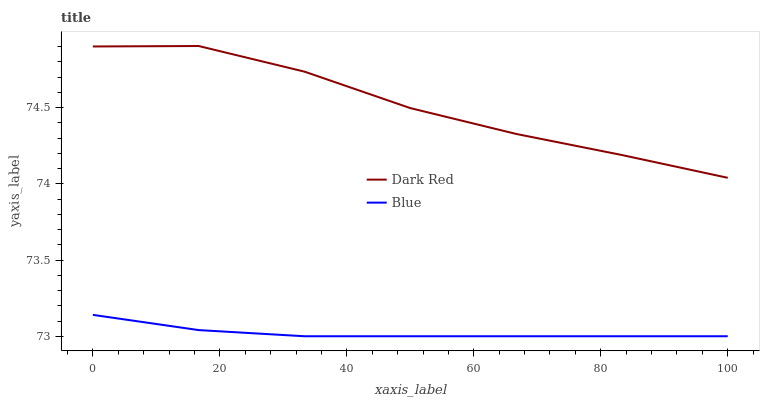Does Blue have the minimum area under the curve?
Answer yes or no. Yes. Does Dark Red have the maximum area under the curve?
Answer yes or no. Yes. Does Dark Red have the minimum area under the curve?
Answer yes or no. No. Is Blue the smoothest?
Answer yes or no. Yes. Is Dark Red the roughest?
Answer yes or no. Yes. Is Dark Red the smoothest?
Answer yes or no. No. Does Blue have the lowest value?
Answer yes or no. Yes. Does Dark Red have the lowest value?
Answer yes or no. No. Does Dark Red have the highest value?
Answer yes or no. Yes. Is Blue less than Dark Red?
Answer yes or no. Yes. Is Dark Red greater than Blue?
Answer yes or no. Yes. Does Blue intersect Dark Red?
Answer yes or no. No. 